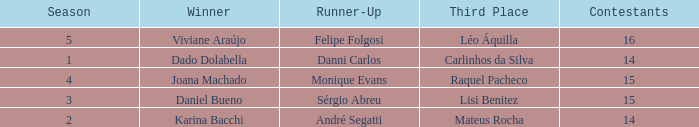How many contestants were there when the runner-up was Monique Evans? 15.0. 